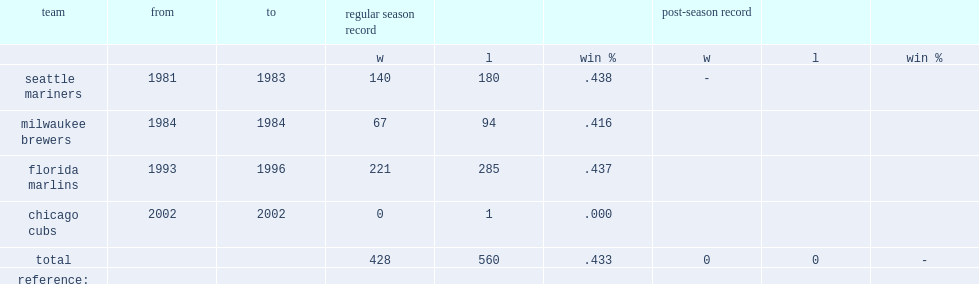What was the record(%) of lachermann in florida marlins? 0.437. 